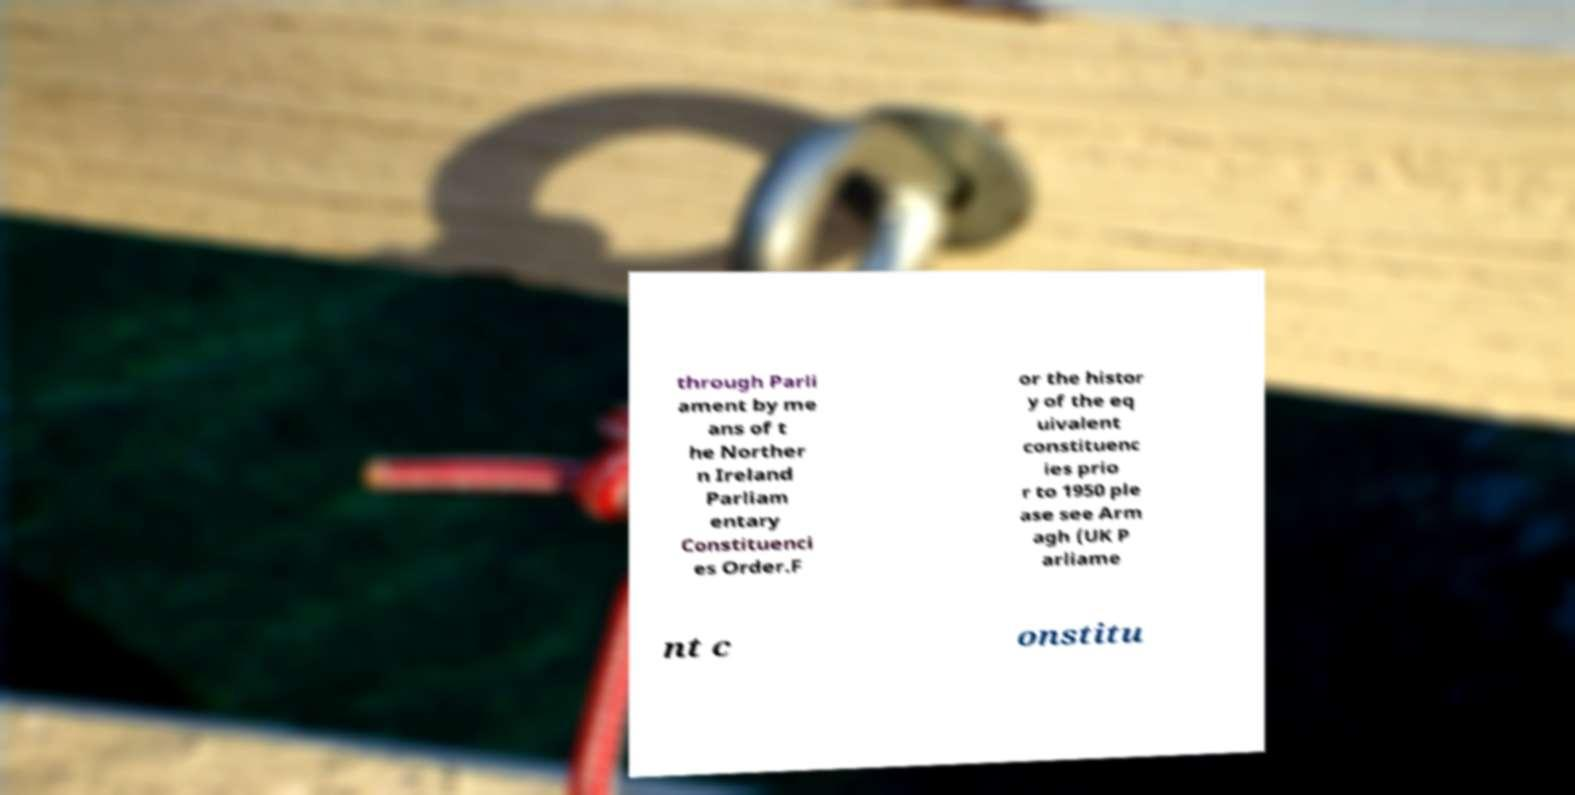Please identify and transcribe the text found in this image. through Parli ament by me ans of t he Norther n Ireland Parliam entary Constituenci es Order.F or the histor y of the eq uivalent constituenc ies prio r to 1950 ple ase see Arm agh (UK P arliame nt c onstitu 